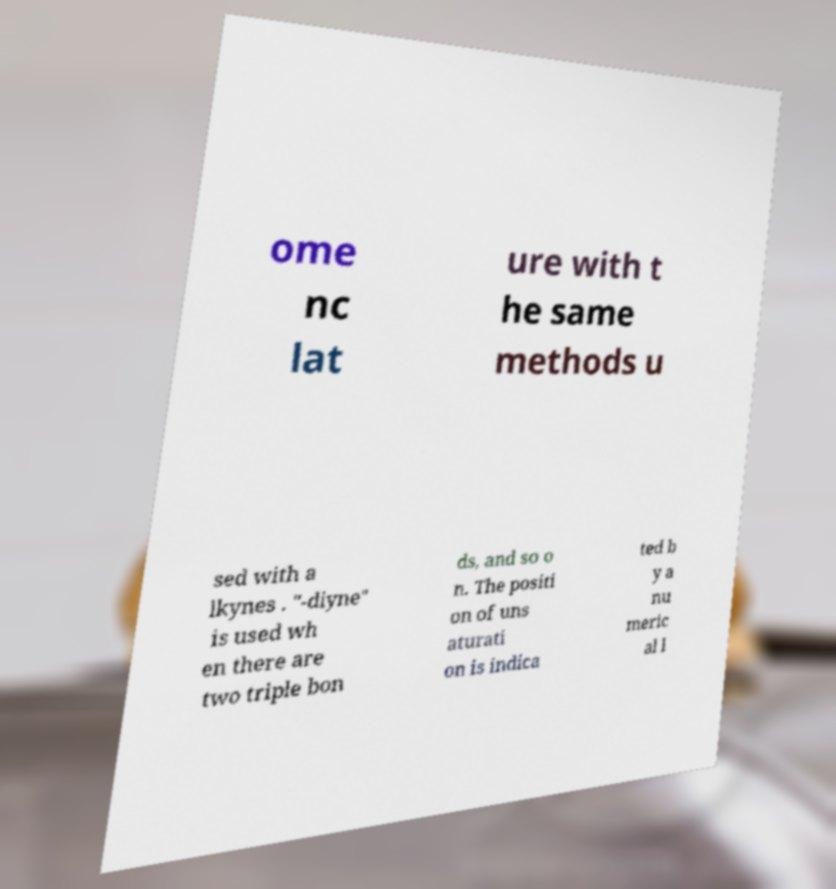I need the written content from this picture converted into text. Can you do that? ome nc lat ure with t he same methods u sed with a lkynes . "-diyne" is used wh en there are two triple bon ds, and so o n. The positi on of uns aturati on is indica ted b y a nu meric al l 